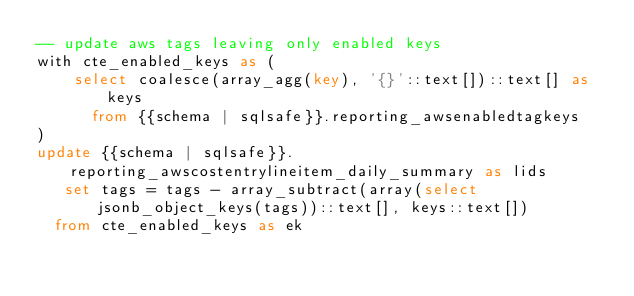<code> <loc_0><loc_0><loc_500><loc_500><_SQL_>-- update aws tags leaving only enabled keys
with cte_enabled_keys as (
    select coalesce(array_agg(key), '{}'::text[])::text[] as keys
      from {{schema | sqlsafe}}.reporting_awsenabledtagkeys
)
update {{schema | sqlsafe}}.reporting_awscostentrylineitem_daily_summary as lids
   set tags = tags - array_subtract(array(select jsonb_object_keys(tags))::text[], keys::text[])
  from cte_enabled_keys as ek</code> 